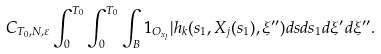Convert formula to latex. <formula><loc_0><loc_0><loc_500><loc_500>C _ { T _ { 0 } , N , \varepsilon } \int _ { 0 } ^ { T _ { 0 } } \int _ { 0 } ^ { T _ { 0 } } \int _ { B } 1 _ { O _ { x _ { l } } } | h _ { k } ( s _ { 1 } , X _ { j } ( s _ { 1 } ) , \xi ^ { \prime \prime } ) d s d s _ { 1 } d \xi ^ { \prime } d \xi ^ { \prime \prime } .</formula> 